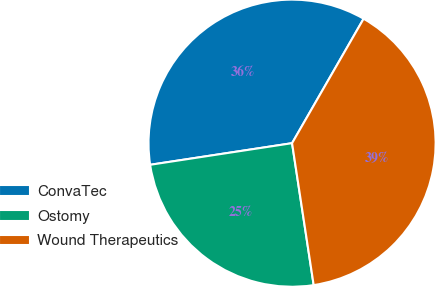<chart> <loc_0><loc_0><loc_500><loc_500><pie_chart><fcel>ConvaTec<fcel>Ostomy<fcel>Wound Therapeutics<nl><fcel>35.71%<fcel>25.0%<fcel>39.29%<nl></chart> 